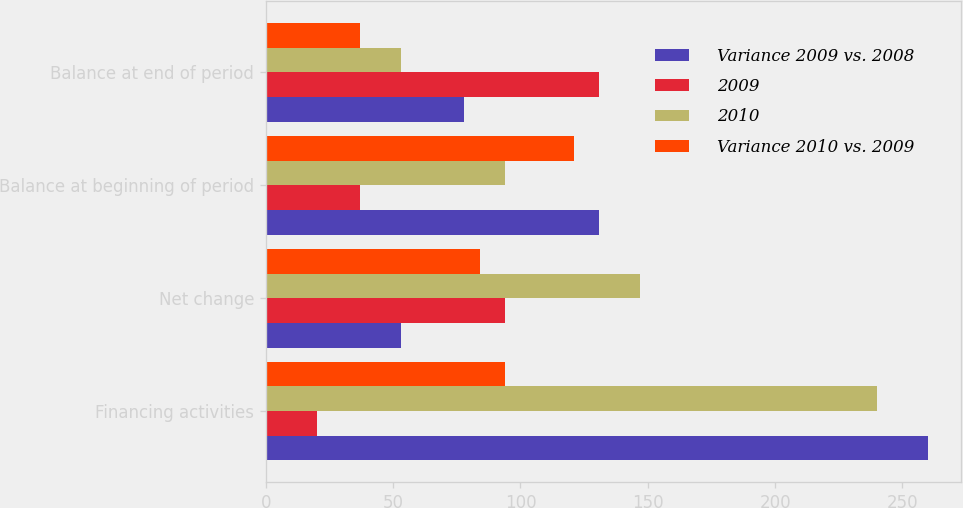<chart> <loc_0><loc_0><loc_500><loc_500><stacked_bar_chart><ecel><fcel>Financing activities<fcel>Net change<fcel>Balance at beginning of period<fcel>Balance at end of period<nl><fcel>Variance 2009 vs. 2008<fcel>260<fcel>53<fcel>131<fcel>78<nl><fcel>2009<fcel>20<fcel>94<fcel>37<fcel>131<nl><fcel>2010<fcel>240<fcel>147<fcel>94<fcel>53<nl><fcel>Variance 2010 vs. 2009<fcel>94<fcel>84<fcel>121<fcel>37<nl></chart> 